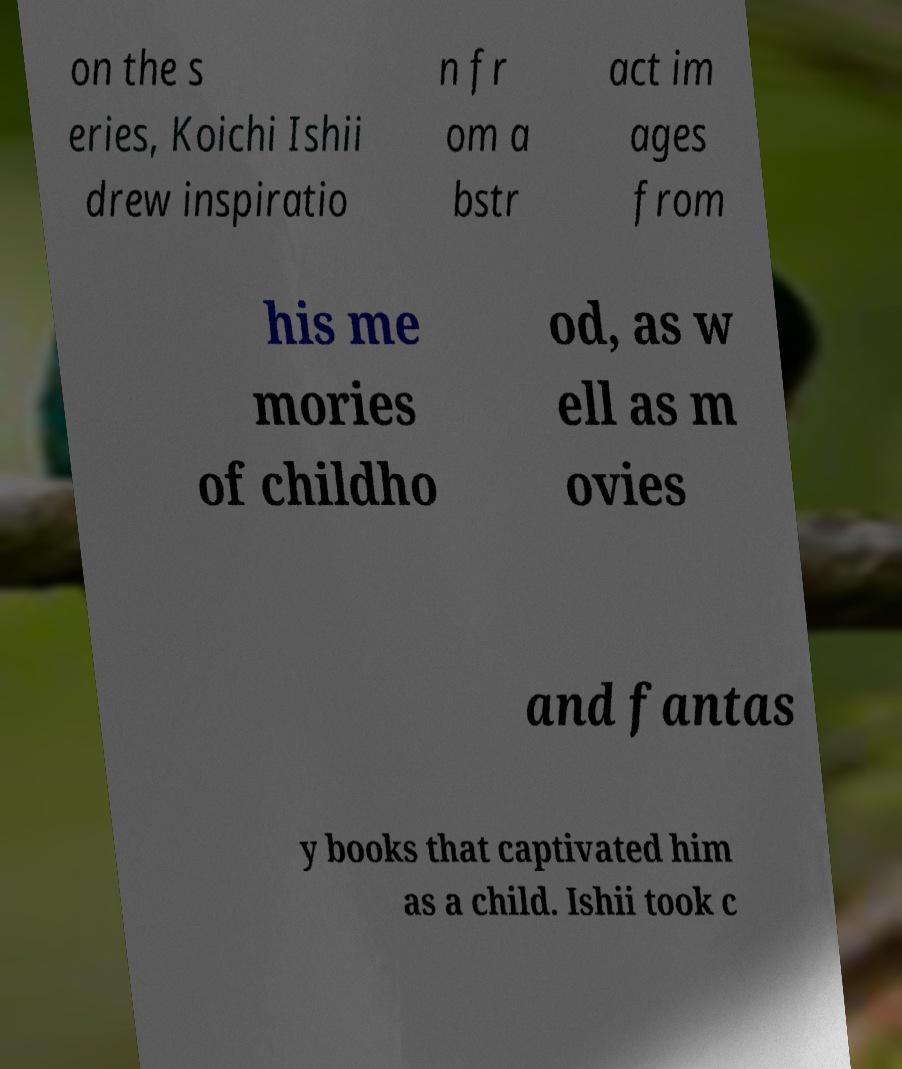Please read and relay the text visible in this image. What does it say? on the s eries, Koichi Ishii drew inspiratio n fr om a bstr act im ages from his me mories of childho od, as w ell as m ovies and fantas y books that captivated him as a child. Ishii took c 